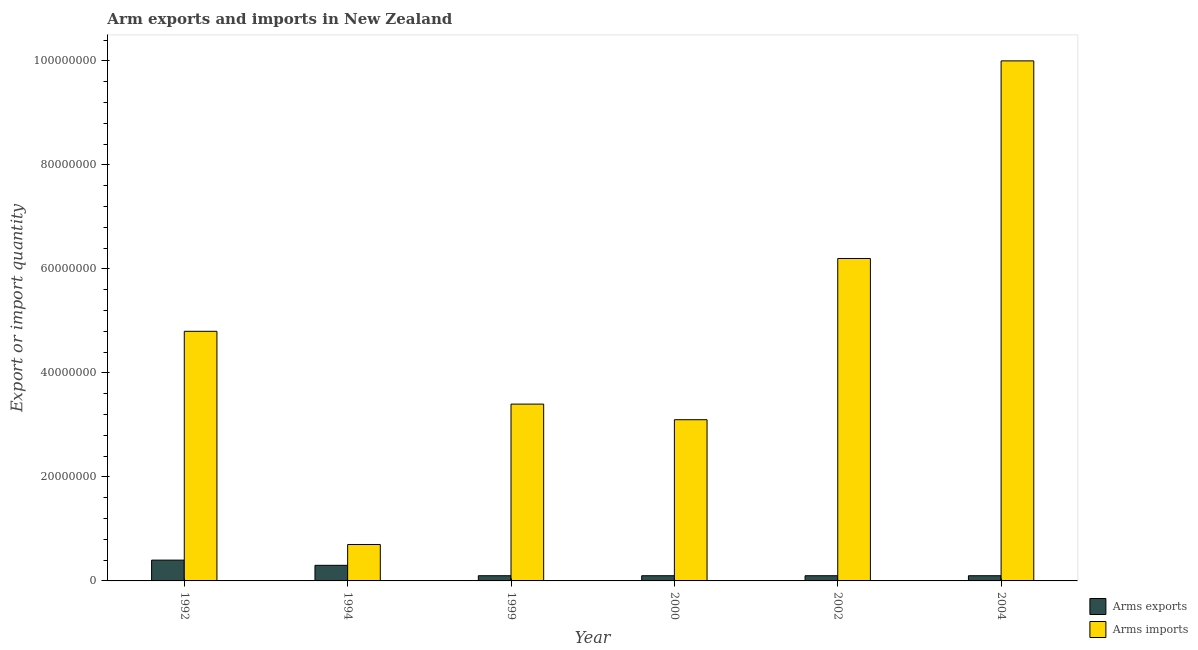How many different coloured bars are there?
Your answer should be very brief. 2. How many groups of bars are there?
Your response must be concise. 6. Are the number of bars on each tick of the X-axis equal?
Offer a very short reply. Yes. How many bars are there on the 2nd tick from the right?
Give a very brief answer. 2. What is the label of the 4th group of bars from the left?
Your response must be concise. 2000. What is the arms imports in 1992?
Your answer should be compact. 4.80e+07. Across all years, what is the maximum arms exports?
Your answer should be compact. 4.00e+06. Across all years, what is the minimum arms imports?
Your response must be concise. 7.00e+06. What is the total arms imports in the graph?
Make the answer very short. 2.82e+08. What is the difference between the arms exports in 1992 and that in 1994?
Provide a short and direct response. 1.00e+06. What is the average arms exports per year?
Keep it short and to the point. 1.83e+06. What is the ratio of the arms imports in 2002 to that in 2004?
Keep it short and to the point. 0.62. Is the difference between the arms imports in 1999 and 2002 greater than the difference between the arms exports in 1999 and 2002?
Make the answer very short. No. What is the difference between the highest and the lowest arms exports?
Your response must be concise. 3.00e+06. In how many years, is the arms imports greater than the average arms imports taken over all years?
Your answer should be compact. 3. What does the 1st bar from the left in 1999 represents?
Your response must be concise. Arms exports. What does the 2nd bar from the right in 1999 represents?
Keep it short and to the point. Arms exports. How many bars are there?
Your answer should be compact. 12. Are the values on the major ticks of Y-axis written in scientific E-notation?
Make the answer very short. No. Does the graph contain any zero values?
Your answer should be very brief. No. Where does the legend appear in the graph?
Your answer should be compact. Bottom right. What is the title of the graph?
Offer a very short reply. Arm exports and imports in New Zealand. What is the label or title of the Y-axis?
Make the answer very short. Export or import quantity. What is the Export or import quantity in Arms exports in 1992?
Ensure brevity in your answer.  4.00e+06. What is the Export or import quantity of Arms imports in 1992?
Provide a succinct answer. 4.80e+07. What is the Export or import quantity of Arms exports in 1994?
Offer a terse response. 3.00e+06. What is the Export or import quantity of Arms imports in 1994?
Give a very brief answer. 7.00e+06. What is the Export or import quantity in Arms exports in 1999?
Provide a short and direct response. 1.00e+06. What is the Export or import quantity in Arms imports in 1999?
Your answer should be compact. 3.40e+07. What is the Export or import quantity of Arms exports in 2000?
Offer a terse response. 1.00e+06. What is the Export or import quantity in Arms imports in 2000?
Offer a terse response. 3.10e+07. What is the Export or import quantity of Arms exports in 2002?
Your answer should be very brief. 1.00e+06. What is the Export or import quantity in Arms imports in 2002?
Keep it short and to the point. 6.20e+07. What is the Export or import quantity in Arms imports in 2004?
Your response must be concise. 1.00e+08. Across all years, what is the maximum Export or import quantity of Arms imports?
Offer a terse response. 1.00e+08. What is the total Export or import quantity of Arms exports in the graph?
Ensure brevity in your answer.  1.10e+07. What is the total Export or import quantity of Arms imports in the graph?
Give a very brief answer. 2.82e+08. What is the difference between the Export or import quantity of Arms imports in 1992 and that in 1994?
Ensure brevity in your answer.  4.10e+07. What is the difference between the Export or import quantity in Arms exports in 1992 and that in 1999?
Keep it short and to the point. 3.00e+06. What is the difference between the Export or import quantity in Arms imports in 1992 and that in 1999?
Provide a short and direct response. 1.40e+07. What is the difference between the Export or import quantity of Arms exports in 1992 and that in 2000?
Offer a terse response. 3.00e+06. What is the difference between the Export or import quantity in Arms imports in 1992 and that in 2000?
Offer a very short reply. 1.70e+07. What is the difference between the Export or import quantity of Arms imports in 1992 and that in 2002?
Your answer should be compact. -1.40e+07. What is the difference between the Export or import quantity of Arms imports in 1992 and that in 2004?
Your answer should be compact. -5.20e+07. What is the difference between the Export or import quantity of Arms imports in 1994 and that in 1999?
Ensure brevity in your answer.  -2.70e+07. What is the difference between the Export or import quantity of Arms exports in 1994 and that in 2000?
Your response must be concise. 2.00e+06. What is the difference between the Export or import quantity in Arms imports in 1994 and that in 2000?
Your answer should be compact. -2.40e+07. What is the difference between the Export or import quantity in Arms imports in 1994 and that in 2002?
Your answer should be compact. -5.50e+07. What is the difference between the Export or import quantity of Arms imports in 1994 and that in 2004?
Your answer should be very brief. -9.30e+07. What is the difference between the Export or import quantity in Arms exports in 1999 and that in 2000?
Ensure brevity in your answer.  0. What is the difference between the Export or import quantity in Arms imports in 1999 and that in 2000?
Your response must be concise. 3.00e+06. What is the difference between the Export or import quantity in Arms exports in 1999 and that in 2002?
Offer a terse response. 0. What is the difference between the Export or import quantity of Arms imports in 1999 and that in 2002?
Your answer should be compact. -2.80e+07. What is the difference between the Export or import quantity in Arms imports in 1999 and that in 2004?
Your answer should be compact. -6.60e+07. What is the difference between the Export or import quantity in Arms imports in 2000 and that in 2002?
Keep it short and to the point. -3.10e+07. What is the difference between the Export or import quantity of Arms exports in 2000 and that in 2004?
Provide a short and direct response. 0. What is the difference between the Export or import quantity of Arms imports in 2000 and that in 2004?
Offer a terse response. -6.90e+07. What is the difference between the Export or import quantity of Arms imports in 2002 and that in 2004?
Provide a succinct answer. -3.80e+07. What is the difference between the Export or import quantity of Arms exports in 1992 and the Export or import quantity of Arms imports in 1994?
Provide a succinct answer. -3.00e+06. What is the difference between the Export or import quantity in Arms exports in 1992 and the Export or import quantity in Arms imports in 1999?
Give a very brief answer. -3.00e+07. What is the difference between the Export or import quantity in Arms exports in 1992 and the Export or import quantity in Arms imports in 2000?
Your answer should be very brief. -2.70e+07. What is the difference between the Export or import quantity in Arms exports in 1992 and the Export or import quantity in Arms imports in 2002?
Your answer should be very brief. -5.80e+07. What is the difference between the Export or import quantity of Arms exports in 1992 and the Export or import quantity of Arms imports in 2004?
Your answer should be compact. -9.60e+07. What is the difference between the Export or import quantity of Arms exports in 1994 and the Export or import quantity of Arms imports in 1999?
Provide a short and direct response. -3.10e+07. What is the difference between the Export or import quantity in Arms exports in 1994 and the Export or import quantity in Arms imports in 2000?
Provide a succinct answer. -2.80e+07. What is the difference between the Export or import quantity in Arms exports in 1994 and the Export or import quantity in Arms imports in 2002?
Your answer should be compact. -5.90e+07. What is the difference between the Export or import quantity of Arms exports in 1994 and the Export or import quantity of Arms imports in 2004?
Make the answer very short. -9.70e+07. What is the difference between the Export or import quantity in Arms exports in 1999 and the Export or import quantity in Arms imports in 2000?
Provide a succinct answer. -3.00e+07. What is the difference between the Export or import quantity of Arms exports in 1999 and the Export or import quantity of Arms imports in 2002?
Make the answer very short. -6.10e+07. What is the difference between the Export or import quantity in Arms exports in 1999 and the Export or import quantity in Arms imports in 2004?
Offer a very short reply. -9.90e+07. What is the difference between the Export or import quantity in Arms exports in 2000 and the Export or import quantity in Arms imports in 2002?
Your answer should be very brief. -6.10e+07. What is the difference between the Export or import quantity of Arms exports in 2000 and the Export or import quantity of Arms imports in 2004?
Give a very brief answer. -9.90e+07. What is the difference between the Export or import quantity in Arms exports in 2002 and the Export or import quantity in Arms imports in 2004?
Ensure brevity in your answer.  -9.90e+07. What is the average Export or import quantity of Arms exports per year?
Provide a short and direct response. 1.83e+06. What is the average Export or import quantity of Arms imports per year?
Give a very brief answer. 4.70e+07. In the year 1992, what is the difference between the Export or import quantity in Arms exports and Export or import quantity in Arms imports?
Offer a very short reply. -4.40e+07. In the year 1999, what is the difference between the Export or import quantity in Arms exports and Export or import quantity in Arms imports?
Provide a succinct answer. -3.30e+07. In the year 2000, what is the difference between the Export or import quantity of Arms exports and Export or import quantity of Arms imports?
Make the answer very short. -3.00e+07. In the year 2002, what is the difference between the Export or import quantity of Arms exports and Export or import quantity of Arms imports?
Your response must be concise. -6.10e+07. In the year 2004, what is the difference between the Export or import quantity in Arms exports and Export or import quantity in Arms imports?
Offer a terse response. -9.90e+07. What is the ratio of the Export or import quantity in Arms exports in 1992 to that in 1994?
Keep it short and to the point. 1.33. What is the ratio of the Export or import quantity of Arms imports in 1992 to that in 1994?
Provide a short and direct response. 6.86. What is the ratio of the Export or import quantity of Arms imports in 1992 to that in 1999?
Your answer should be very brief. 1.41. What is the ratio of the Export or import quantity in Arms exports in 1992 to that in 2000?
Give a very brief answer. 4. What is the ratio of the Export or import quantity in Arms imports in 1992 to that in 2000?
Give a very brief answer. 1.55. What is the ratio of the Export or import quantity in Arms imports in 1992 to that in 2002?
Offer a very short reply. 0.77. What is the ratio of the Export or import quantity in Arms imports in 1992 to that in 2004?
Offer a terse response. 0.48. What is the ratio of the Export or import quantity in Arms imports in 1994 to that in 1999?
Ensure brevity in your answer.  0.21. What is the ratio of the Export or import quantity of Arms imports in 1994 to that in 2000?
Keep it short and to the point. 0.23. What is the ratio of the Export or import quantity of Arms exports in 1994 to that in 2002?
Your answer should be compact. 3. What is the ratio of the Export or import quantity of Arms imports in 1994 to that in 2002?
Provide a succinct answer. 0.11. What is the ratio of the Export or import quantity in Arms exports in 1994 to that in 2004?
Your answer should be very brief. 3. What is the ratio of the Export or import quantity in Arms imports in 1994 to that in 2004?
Ensure brevity in your answer.  0.07. What is the ratio of the Export or import quantity of Arms imports in 1999 to that in 2000?
Provide a short and direct response. 1.1. What is the ratio of the Export or import quantity of Arms exports in 1999 to that in 2002?
Make the answer very short. 1. What is the ratio of the Export or import quantity in Arms imports in 1999 to that in 2002?
Your answer should be very brief. 0.55. What is the ratio of the Export or import quantity in Arms imports in 1999 to that in 2004?
Ensure brevity in your answer.  0.34. What is the ratio of the Export or import quantity of Arms exports in 2000 to that in 2002?
Ensure brevity in your answer.  1. What is the ratio of the Export or import quantity of Arms imports in 2000 to that in 2002?
Provide a succinct answer. 0.5. What is the ratio of the Export or import quantity in Arms exports in 2000 to that in 2004?
Offer a terse response. 1. What is the ratio of the Export or import quantity in Arms imports in 2000 to that in 2004?
Offer a terse response. 0.31. What is the ratio of the Export or import quantity in Arms imports in 2002 to that in 2004?
Provide a short and direct response. 0.62. What is the difference between the highest and the second highest Export or import quantity in Arms imports?
Offer a very short reply. 3.80e+07. What is the difference between the highest and the lowest Export or import quantity of Arms imports?
Give a very brief answer. 9.30e+07. 